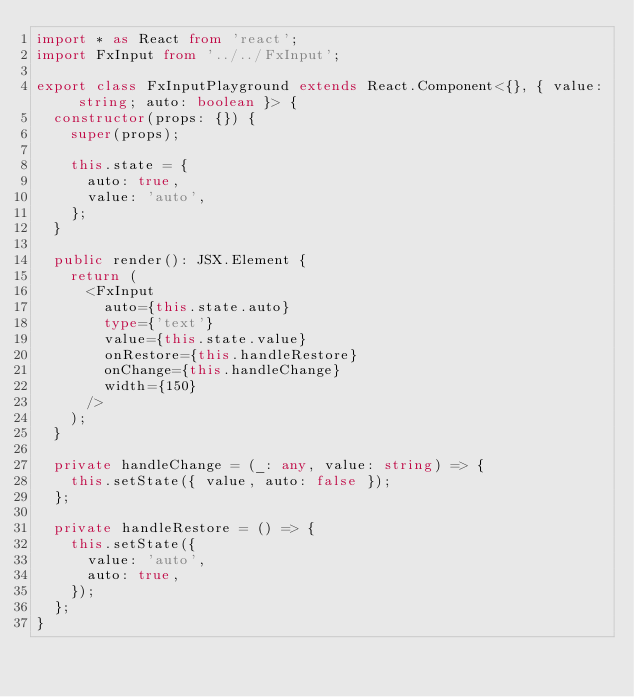Convert code to text. <code><loc_0><loc_0><loc_500><loc_500><_TypeScript_>import * as React from 'react';
import FxInput from '../../FxInput';

export class FxInputPlayground extends React.Component<{}, { value: string; auto: boolean }> {
  constructor(props: {}) {
    super(props);

    this.state = {
      auto: true,
      value: 'auto',
    };
  }

  public render(): JSX.Element {
    return (
      <FxInput
        auto={this.state.auto}
        type={'text'}
        value={this.state.value}
        onRestore={this.handleRestore}
        onChange={this.handleChange}
        width={150}
      />
    );
  }

  private handleChange = (_: any, value: string) => {
    this.setState({ value, auto: false });
  };

  private handleRestore = () => {
    this.setState({
      value: 'auto',
      auto: true,
    });
  };
}
</code> 